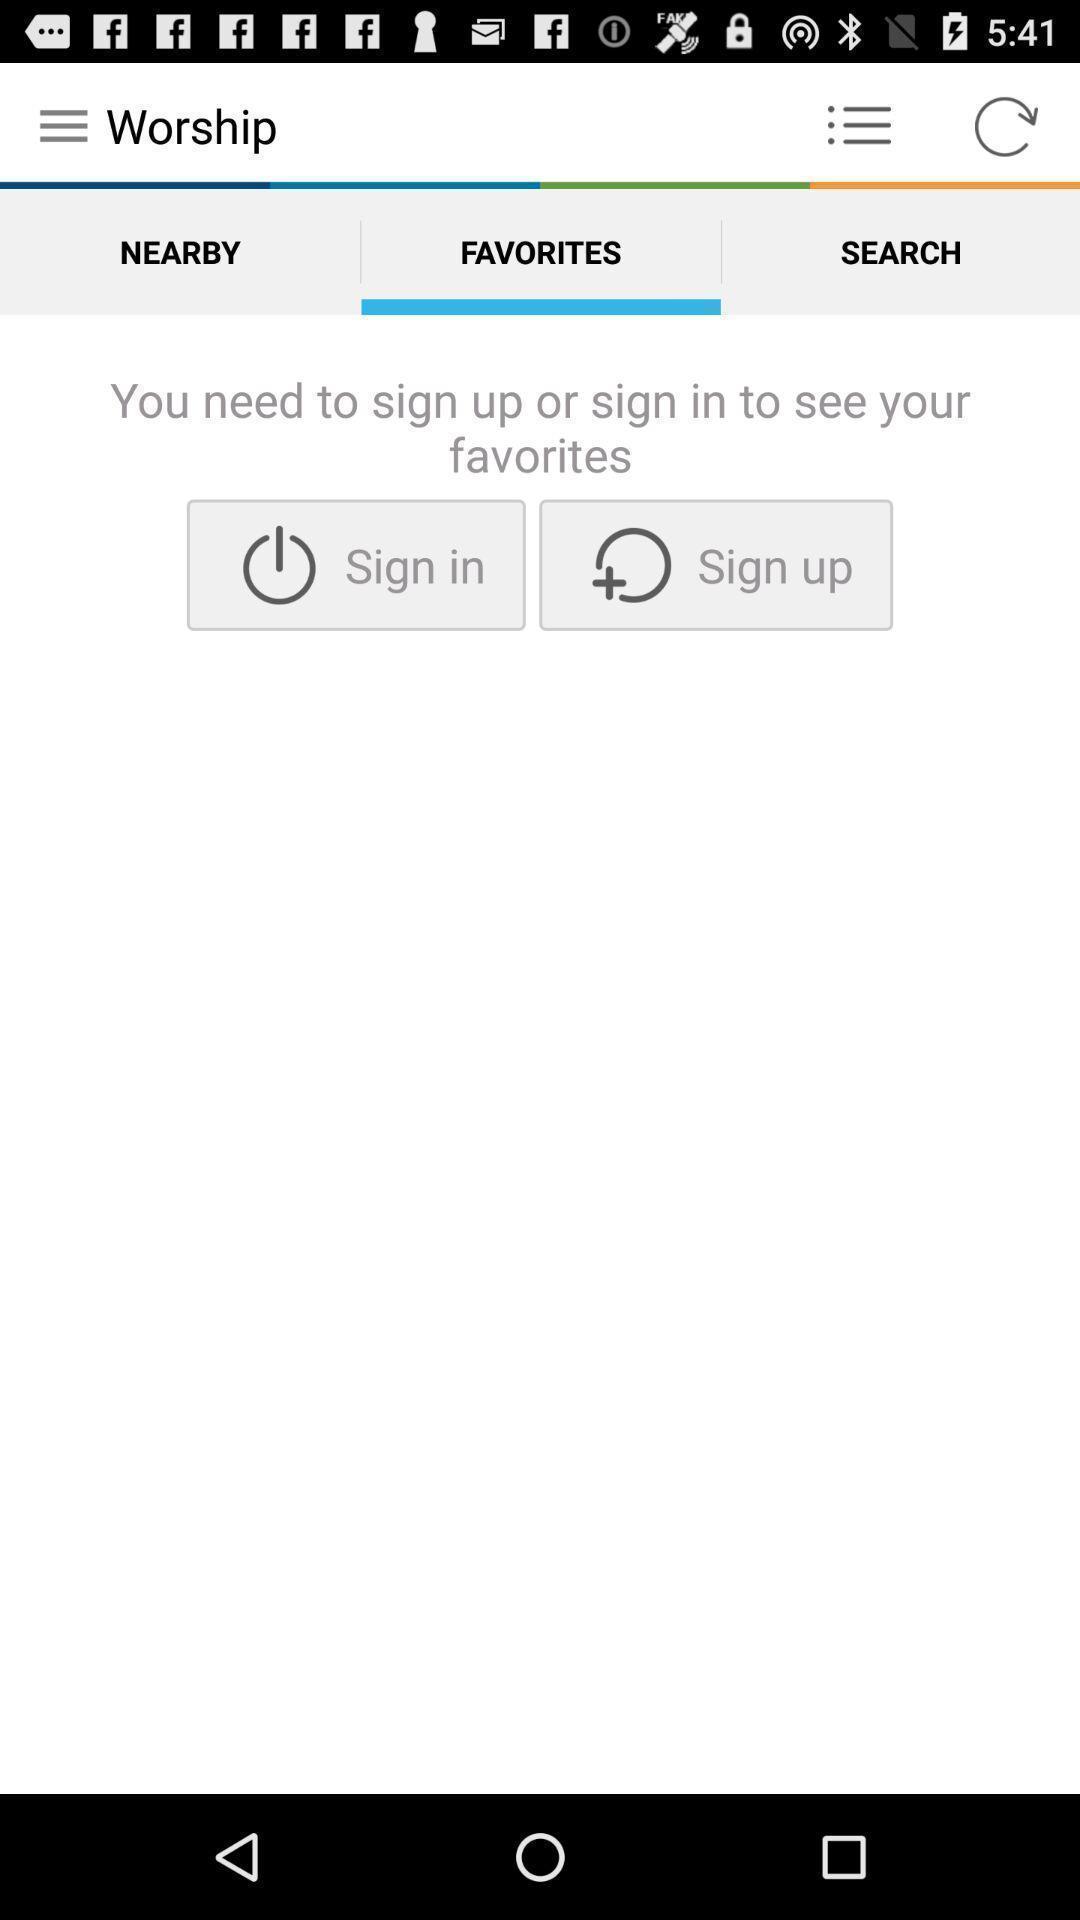Describe the content in this image. Sign in page. 